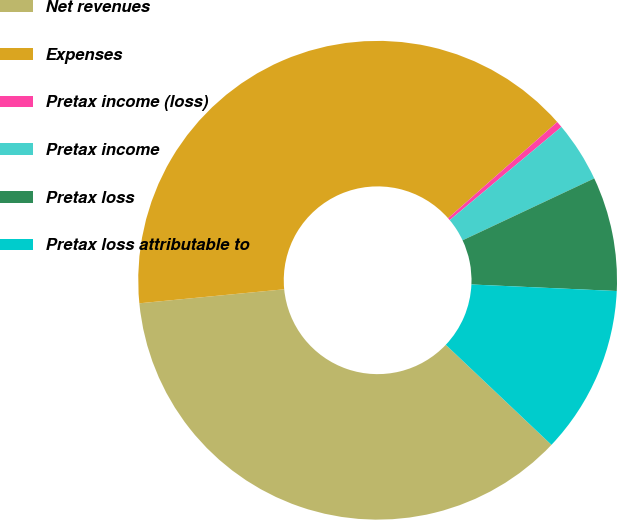Convert chart to OTSL. <chart><loc_0><loc_0><loc_500><loc_500><pie_chart><fcel>Net revenues<fcel>Expenses<fcel>Pretax income (loss)<fcel>Pretax income<fcel>Pretax loss<fcel>Pretax loss attributable to<nl><fcel>36.4%<fcel>40.04%<fcel>0.43%<fcel>4.07%<fcel>7.71%<fcel>11.35%<nl></chart> 